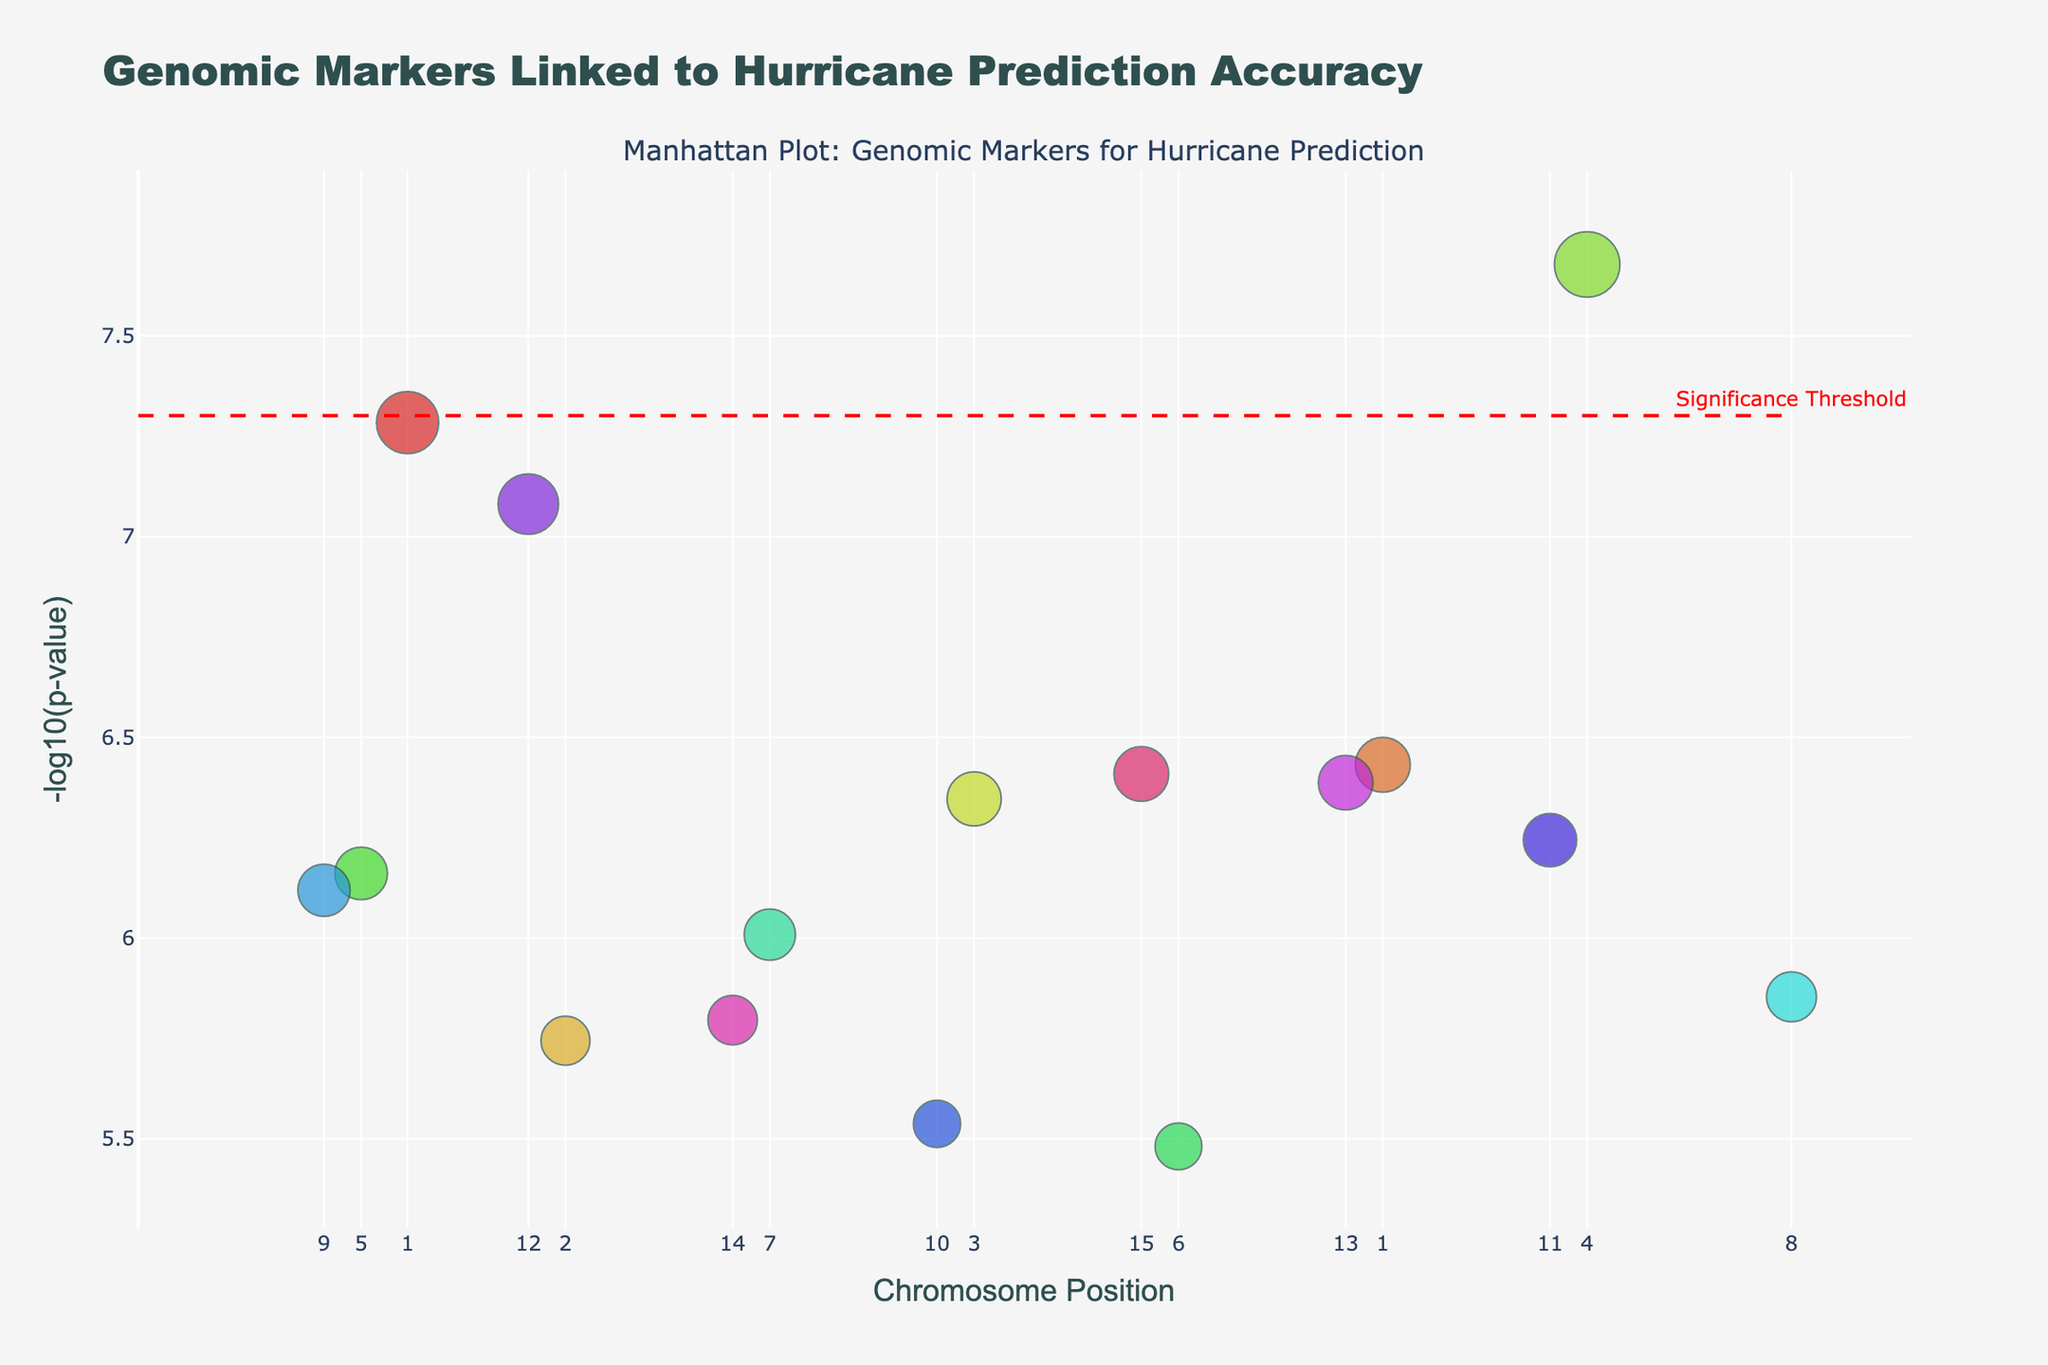What's the title of the figure? The title can be found at the top of the plot, typically rendered in a larger font size. It reads "Genomic Markers Linked to Hurricane Prediction Accuracy".
Answer: Genomic Markers Linked to Hurricane Prediction Accuracy Which axis represents the chromosome position? The x-axis represents the chromosome position, as indicated by the label "Chromosome Position" along the horizontal axis.
Answer: x-axis Which genomic marker has the smallest p-value? The genomic marker with the smallest p-value will be the one with the highest -log10(p-value) on the y-axis. By examining the plot, the marker corresponding to the highest point is on Chromosome 4 at Position 78000000 with a p-value of 2.1e-8.
Answer: NOAA2 How many models are represented in the plot? By counting the number of unique colors in the scatter plot, which are mapped to different models, we can see there are multiple models. Each unique color represents one model. There are 13 unique models.
Answer: 13 Does any genomic marker reach the significance threshold? The significance threshold is marked by a horizontal dashed red line at -log10(5e-8). Any points above this line have reached significance. By looking at the plot, there is at least one point above this line.
Answer: Yes What is the significance threshold in -log10(p-value) terms? The significance threshold line is positioned at -log10(5e-8), which is explicitly annotated in the figure.
Answer: 7.3 Which chromosome has the highest number of markers above -log10(p-value) of 6? To determine this, count the number of points above -log10(p-value) of 6 for each chromosome. Chromosomes with multiple points above this threshold need to be compared. Chromosome 1 has the highest number, with two markers above this threshold.
Answer: Chromosome 1 What color represents the GFS model, and which gene is associated with it? The color representing the GFS model can be identified by locating points tied to the label "Model: GFS" in the hover-over information. The associated gene with Model GFS is NOAA1, and its position happens to be associated with a specific color, which is located at Chromosome 1, Position 14500000.
Answer: A specific shade, NOAA1 Which gene model from Chromosome 15 has the lowest p-value? By hovering over the data points on Chromosome 15, the gene associated with the lowest p-value can be found. The lowest p-value on Chromosome 15 is associated with the NHC4 model.
Answer: NHC4 What is the -log10(p-value) for the genomic marker corresponding to Chromosome 8, Position 89000000? By finding the point at Chromosome 8 with Position 89000000, referring to its height on the y-axis reveals the -log10(p-value) value. The marker has a -log10(p-value) of approximately 5.85.
Answer: 5.85 